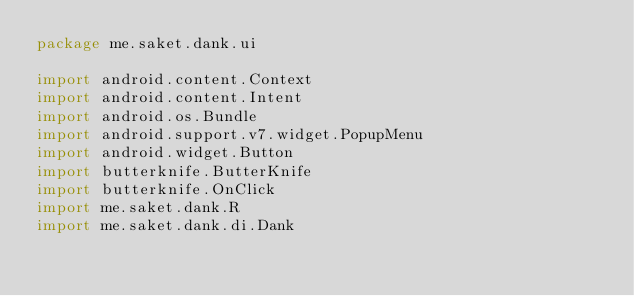<code> <loc_0><loc_0><loc_500><loc_500><_Kotlin_>package me.saket.dank.ui

import android.content.Context
import android.content.Intent
import android.os.Bundle
import android.support.v7.widget.PopupMenu
import android.widget.Button
import butterknife.ButterKnife
import butterknife.OnClick
import me.saket.dank.R
import me.saket.dank.di.Dank</code> 